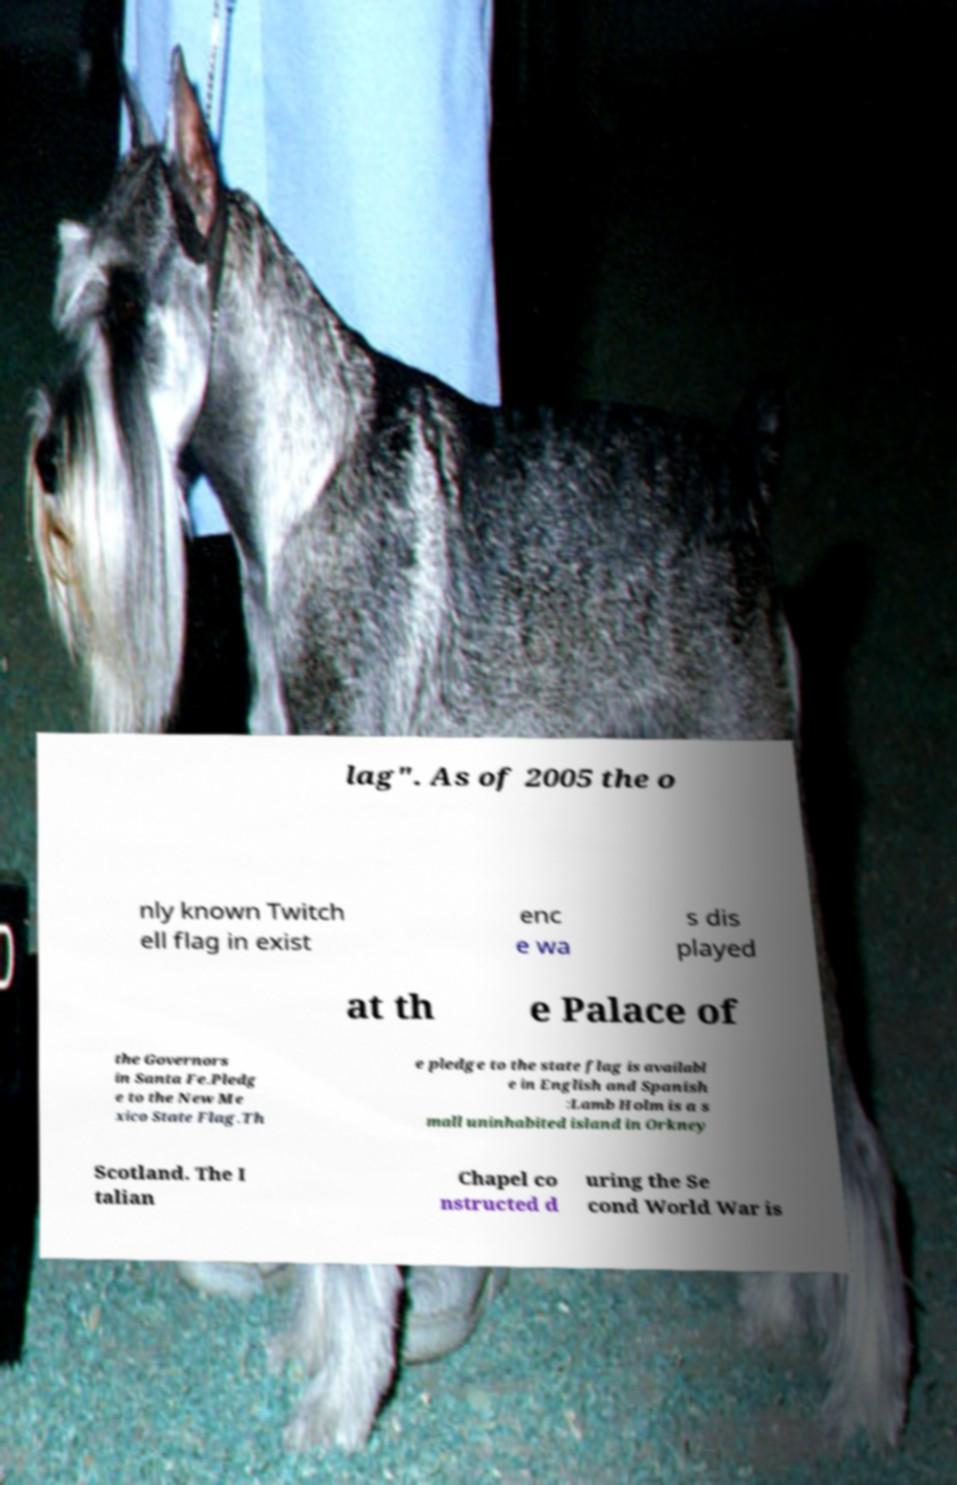What messages or text are displayed in this image? I need them in a readable, typed format. lag". As of 2005 the o nly known Twitch ell flag in exist enc e wa s dis played at th e Palace of the Governors in Santa Fe.Pledg e to the New Me xico State Flag.Th e pledge to the state flag is availabl e in English and Spanish :Lamb Holm is a s mall uninhabited island in Orkney Scotland. The I talian Chapel co nstructed d uring the Se cond World War is 